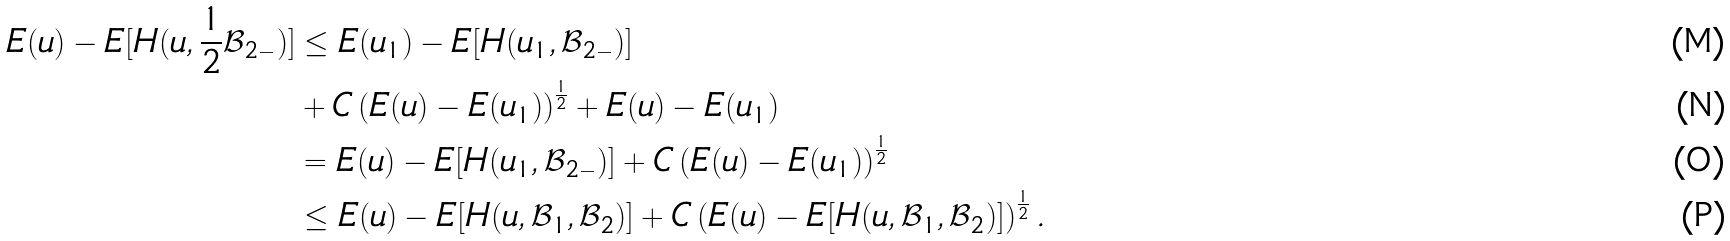<formula> <loc_0><loc_0><loc_500><loc_500>E ( u ) - E [ H ( u , \frac { 1 } { 2 } \mathcal { B } _ { 2 - } ) ] & \leq E ( u _ { 1 } ) - E [ H ( u _ { 1 } , \mathcal { B } _ { 2 - } ) ] \\ & + C \left ( E ( u ) - E ( u _ { 1 } ) \right ) ^ { \frac { 1 } { 2 } } + E ( u ) - E ( u _ { 1 } ) \\ & = E ( u ) - E [ H ( u _ { 1 } , \mathcal { B } _ { 2 - } ) ] + C \left ( E ( u ) - E ( u _ { 1 } ) \right ) ^ { \frac { 1 } { 2 } } \\ & \leq E ( u ) - E [ H ( u , \mathcal { B } _ { 1 } , \mathcal { B } _ { 2 } ) ] + C \left ( E ( u ) - E [ H ( u , \mathcal { B } _ { 1 } , \mathcal { B } _ { 2 } ) ] \right ) ^ { \frac { 1 } { 2 } } .</formula> 